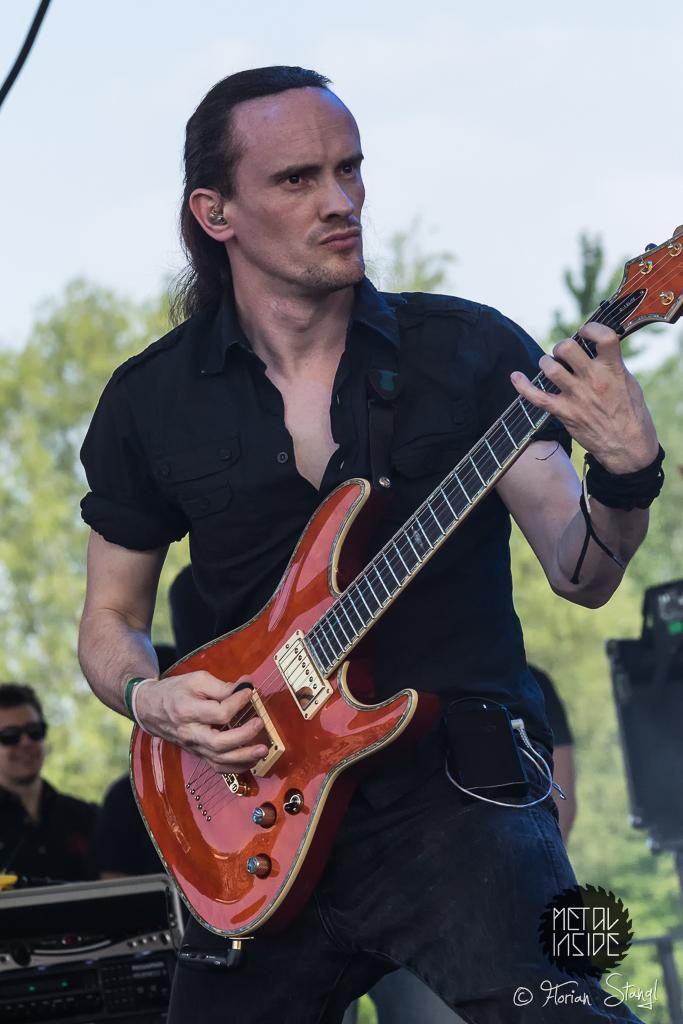What is the main subject of the image? There is a man in the image. What is the man doing in the image? The man is playing a guitar. Does the man have a tail in the image? No, the man does not have a tail in the image. What is the taste of the guitar in the image? Guitars do not have a taste, as they are not edible. 